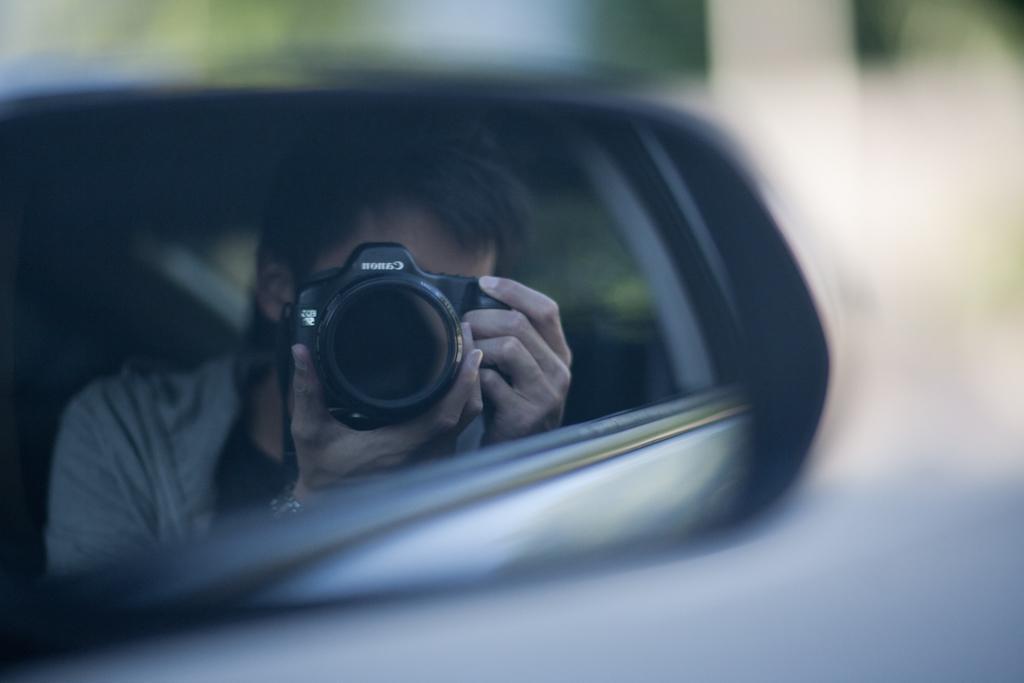Could you give a brief overview of what you see in this image? On the left side of this image there is a mirror. In the mirror, I can see a person who is holding a camera in the hands. The background is blurred. 